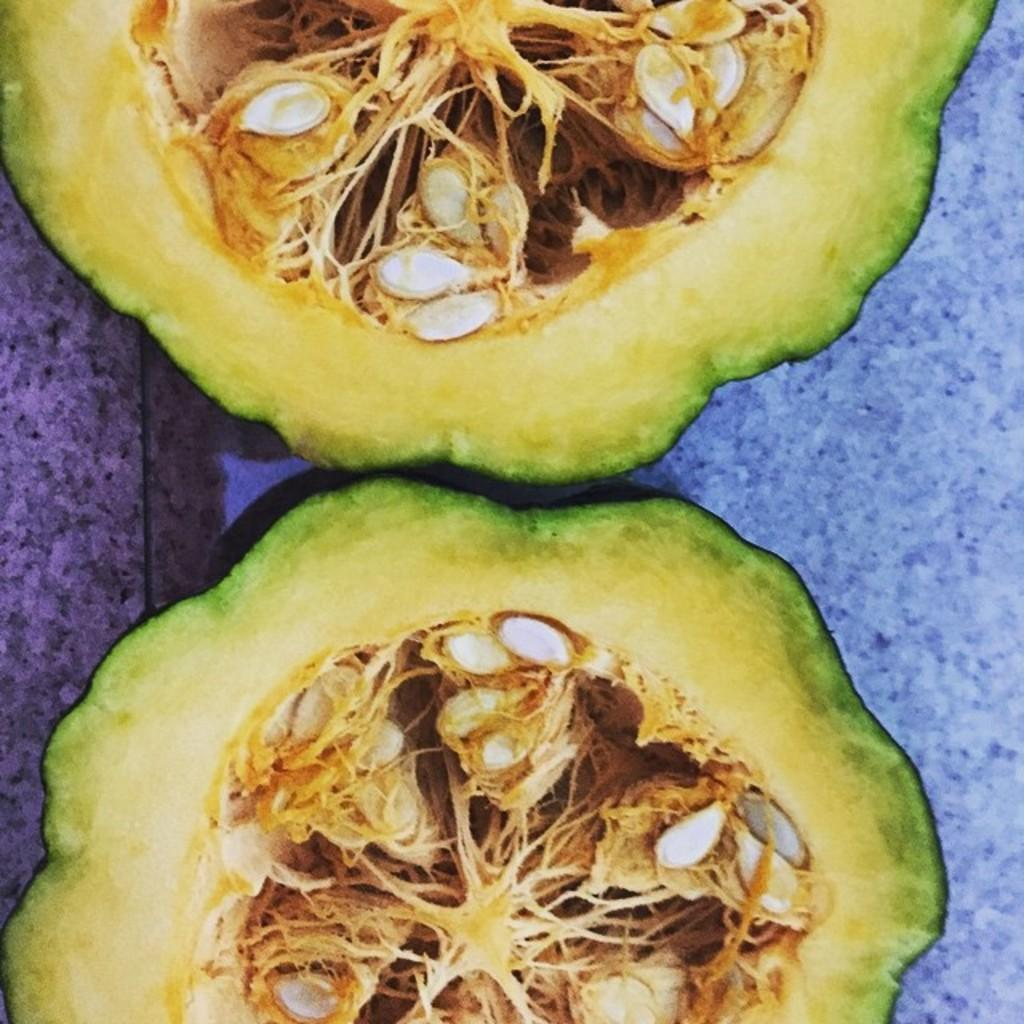What type of vegetable is present in the image? There are two pieces of pumpkins in the image. What can be found inside the pumpkins? The pumpkins have seeds inside them. Can you describe the object on the right side of the image? There is a blue object on the right side of the image. How many ears of corn can be seen in the image? There are no ears of corn present in the image; it features two pieces of pumpkins. What type of seafood is visible in the image? There is no seafood present in the image. 